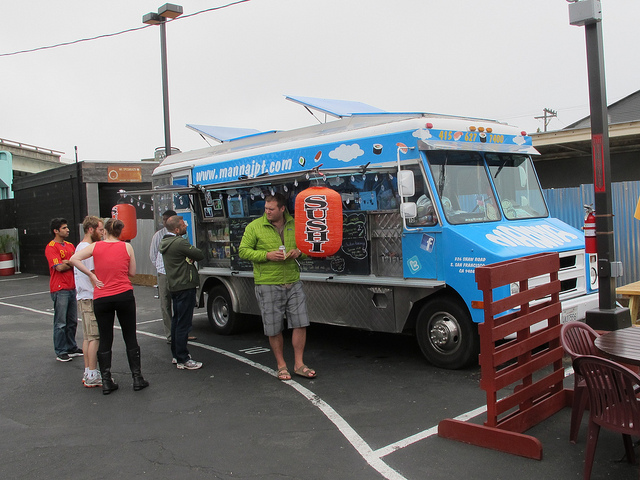<image>What is the best selling product? I am not sure what the best-selling product is. It could be sushi, coffee, sobi, rice, or something else. What type of wire is the man working on? It is unknown what type of wire the man is working on. It may not be a wire. What sort of outerwear does she have on? It is unknown what sort of outerwear she has on. It could be a tank top, jacket or a red shirt. What college does this man support? It is uncertain which college this man supports. It could be 'ku', 'sushi', 'um', 'yale', or none. What is the best selling product? I am not sure what the best selling product is. However, it can be seen that sushi is one of the best selling products. What type of wire is the man working on? I am not sure what type of wire the man is working on. There are conflicting answers and it is ambiguous. What sort of outerwear does she have on? I don't know what sort of outerwear she has on. It can be seen jacket, tank top pants, red shirt, stretch pants, none, tank top, shirt and pants, tank top, pants, or shorts. What college does this man support? I am not sure what college this man supports. It can be 'ku', 'sushi', 'um', or 'yale'. 